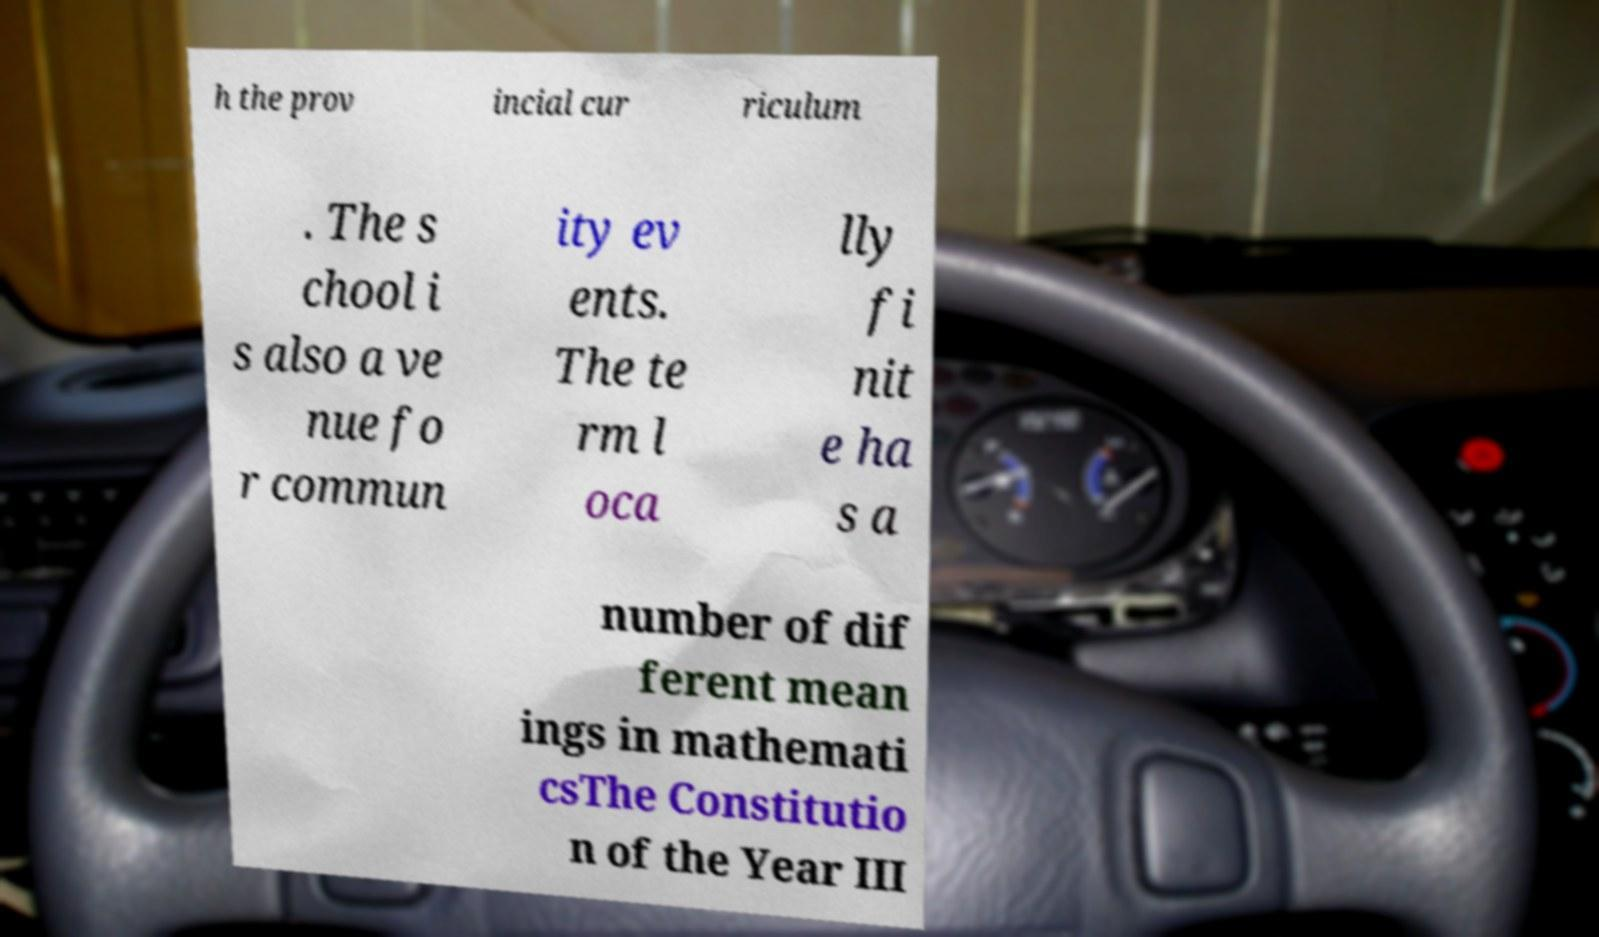Could you assist in decoding the text presented in this image and type it out clearly? h the prov incial cur riculum . The s chool i s also a ve nue fo r commun ity ev ents. The te rm l oca lly fi nit e ha s a number of dif ferent mean ings in mathemati csThe Constitutio n of the Year III 